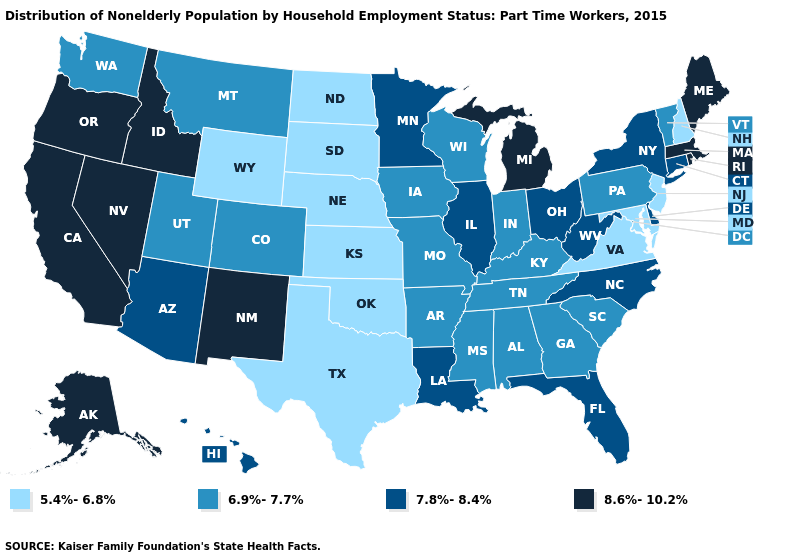Name the states that have a value in the range 5.4%-6.8%?
Be succinct. Kansas, Maryland, Nebraska, New Hampshire, New Jersey, North Dakota, Oklahoma, South Dakota, Texas, Virginia, Wyoming. Name the states that have a value in the range 5.4%-6.8%?
Give a very brief answer. Kansas, Maryland, Nebraska, New Hampshire, New Jersey, North Dakota, Oklahoma, South Dakota, Texas, Virginia, Wyoming. What is the value of New York?
Be succinct. 7.8%-8.4%. Name the states that have a value in the range 8.6%-10.2%?
Give a very brief answer. Alaska, California, Idaho, Maine, Massachusetts, Michigan, Nevada, New Mexico, Oregon, Rhode Island. What is the value of Iowa?
Be succinct. 6.9%-7.7%. Name the states that have a value in the range 6.9%-7.7%?
Answer briefly. Alabama, Arkansas, Colorado, Georgia, Indiana, Iowa, Kentucky, Mississippi, Missouri, Montana, Pennsylvania, South Carolina, Tennessee, Utah, Vermont, Washington, Wisconsin. Name the states that have a value in the range 7.8%-8.4%?
Short answer required. Arizona, Connecticut, Delaware, Florida, Hawaii, Illinois, Louisiana, Minnesota, New York, North Carolina, Ohio, West Virginia. Which states have the highest value in the USA?
Write a very short answer. Alaska, California, Idaho, Maine, Massachusetts, Michigan, Nevada, New Mexico, Oregon, Rhode Island. What is the value of Alabama?
Give a very brief answer. 6.9%-7.7%. What is the value of Ohio?
Give a very brief answer. 7.8%-8.4%. Does Massachusetts have the highest value in the USA?
Keep it brief. Yes. Name the states that have a value in the range 7.8%-8.4%?
Quick response, please. Arizona, Connecticut, Delaware, Florida, Hawaii, Illinois, Louisiana, Minnesota, New York, North Carolina, Ohio, West Virginia. What is the value of New Mexico?
Answer briefly. 8.6%-10.2%. What is the value of Colorado?
Give a very brief answer. 6.9%-7.7%. What is the value of Pennsylvania?
Give a very brief answer. 6.9%-7.7%. 